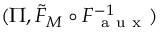<formula> <loc_0><loc_0><loc_500><loc_500>( \Pi , \tilde { F } _ { M } \circ F _ { a u x } ^ { - 1 } )</formula> 